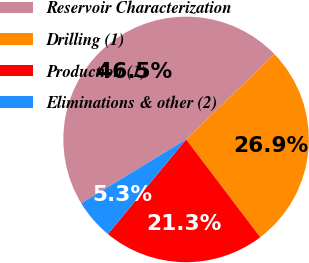<chart> <loc_0><loc_0><loc_500><loc_500><pie_chart><fcel>Reservoir Characterization<fcel>Drilling (1)<fcel>Production (1)<fcel>Eliminations & other (2)<nl><fcel>46.49%<fcel>26.9%<fcel>21.31%<fcel>5.3%<nl></chart> 